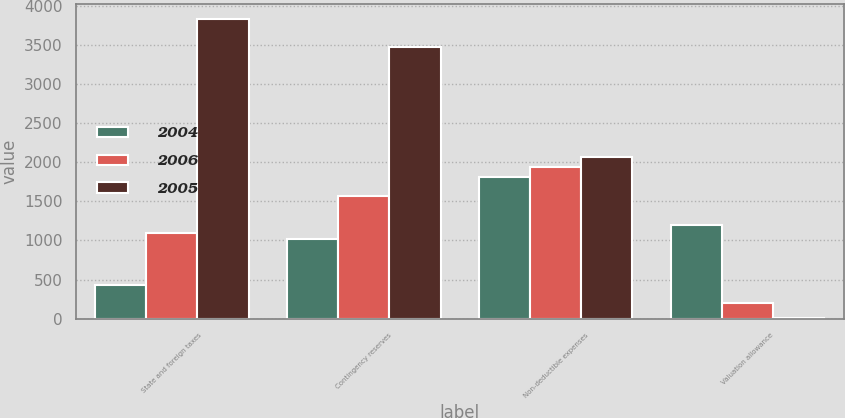<chart> <loc_0><loc_0><loc_500><loc_500><stacked_bar_chart><ecel><fcel>State and foreign taxes<fcel>Contingency reserves<fcel>Non-deductible expenses<fcel>Valuation allowance<nl><fcel>2004<fcel>424<fcel>1025<fcel>1811<fcel>1192<nl><fcel>2006<fcel>1101<fcel>1566<fcel>1940<fcel>203<nl><fcel>2005<fcel>3837<fcel>3476<fcel>2064<fcel>8<nl></chart> 